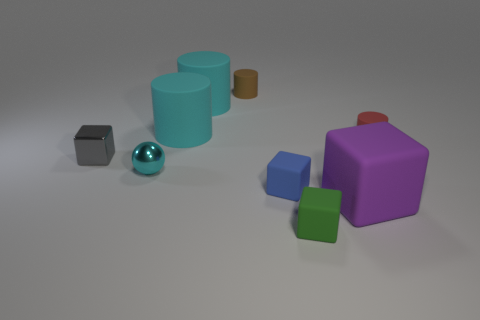What material is the cube that is in front of the tiny gray cube and behind the purple rubber block?
Provide a short and direct response. Rubber. The metal block has what size?
Make the answer very short. Small. How many small balls are behind the small brown rubber object that is behind the tiny cylinder to the right of the purple rubber block?
Provide a succinct answer. 0. There is a tiny thing that is right of the large object in front of the tiny metal ball; what shape is it?
Provide a succinct answer. Cylinder. What size is the brown matte thing that is the same shape as the red matte thing?
Keep it short and to the point. Small. Is there anything else that is the same size as the green rubber block?
Make the answer very short. Yes. There is a rubber cube in front of the large purple matte cube; what is its color?
Keep it short and to the point. Green. What is the material of the big object in front of the cyan thing that is in front of the small matte cylinder in front of the tiny brown matte thing?
Your answer should be compact. Rubber. What size is the cyan thing that is in front of the block that is behind the tiny cyan object?
Ensure brevity in your answer.  Small. There is a large matte object that is the same shape as the gray shiny thing; what color is it?
Your answer should be compact. Purple. 